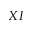<formula> <loc_0><loc_0><loc_500><loc_500>X I</formula> 